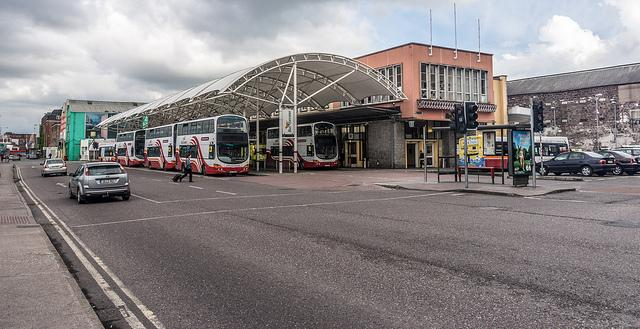What mass transit units sit parked here? buses 